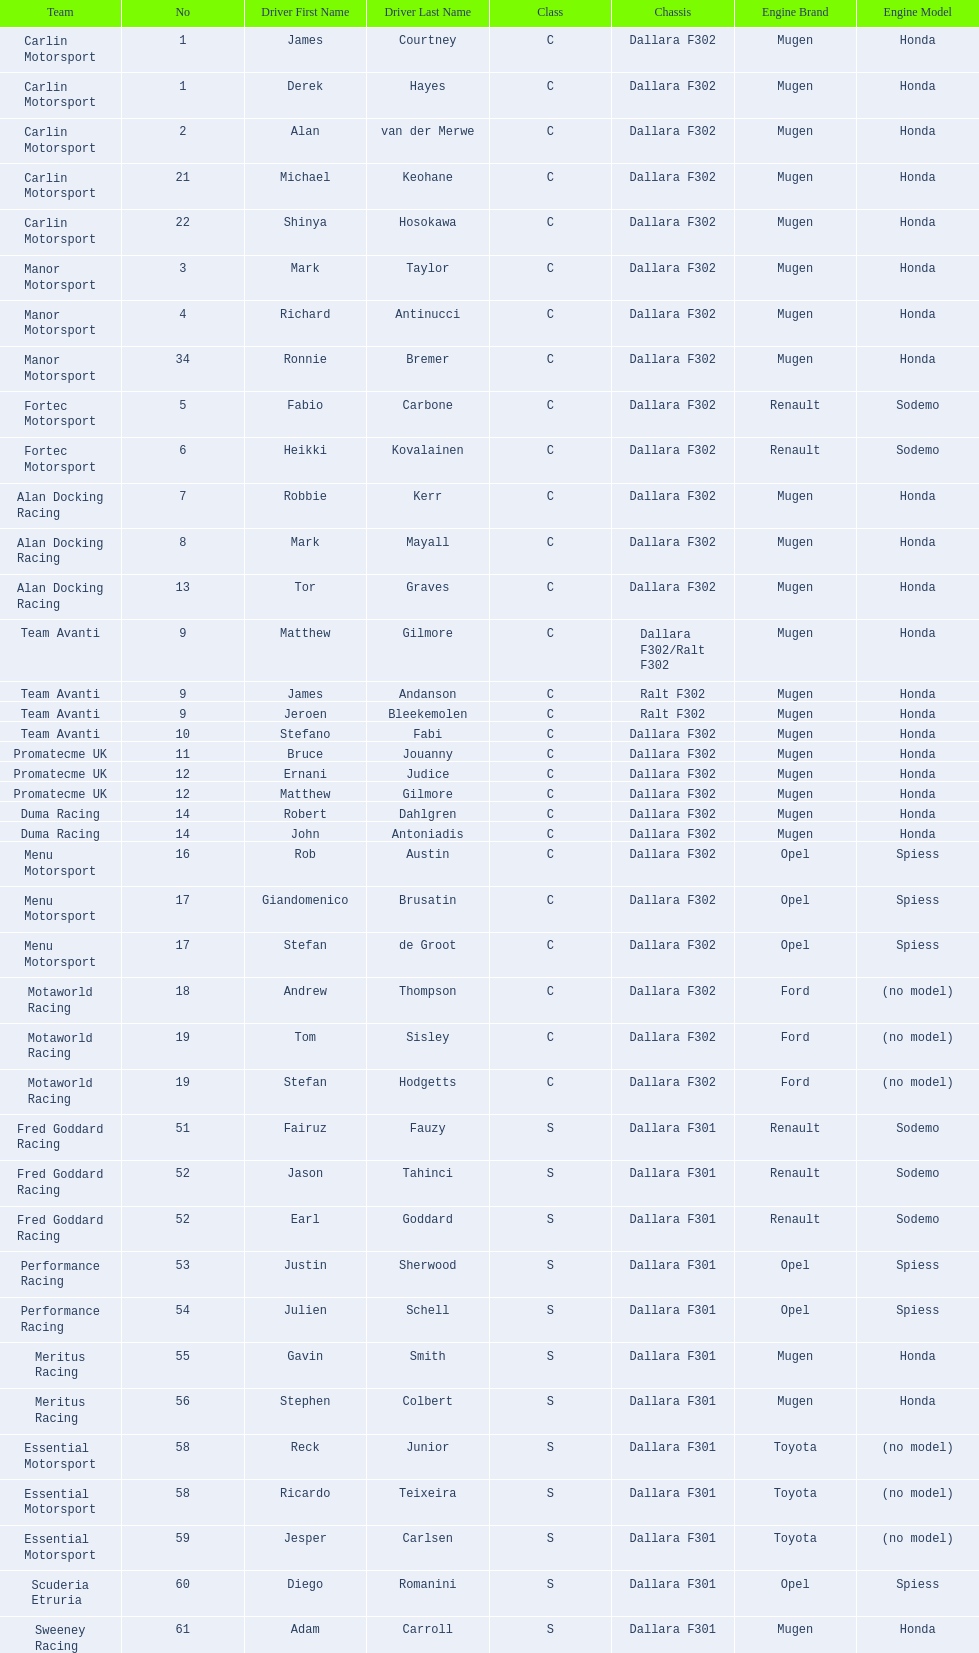How many teams had at least two drivers this season? 17. 